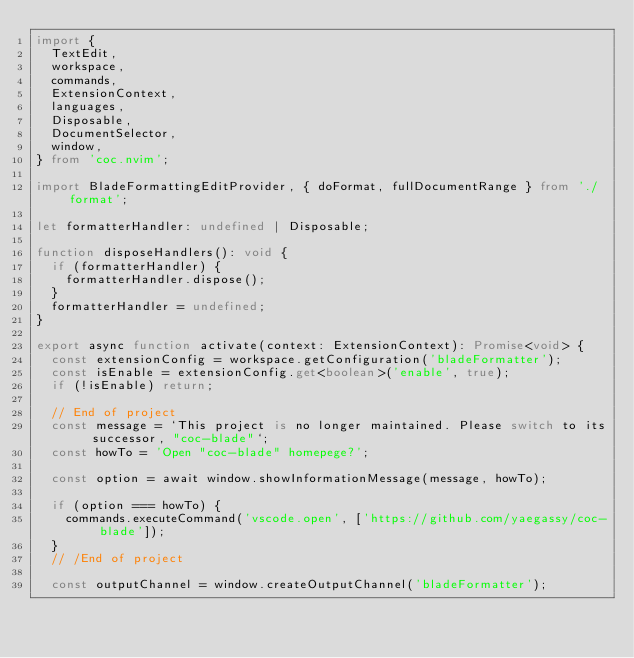<code> <loc_0><loc_0><loc_500><loc_500><_TypeScript_>import {
  TextEdit,
  workspace,
  commands,
  ExtensionContext,
  languages,
  Disposable,
  DocumentSelector,
  window,
} from 'coc.nvim';

import BladeFormattingEditProvider, { doFormat, fullDocumentRange } from './format';

let formatterHandler: undefined | Disposable;

function disposeHandlers(): void {
  if (formatterHandler) {
    formatterHandler.dispose();
  }
  formatterHandler = undefined;
}

export async function activate(context: ExtensionContext): Promise<void> {
  const extensionConfig = workspace.getConfiguration('bladeFormatter');
  const isEnable = extensionConfig.get<boolean>('enable', true);
  if (!isEnable) return;

  // End of project
  const message = `This project is no longer maintained. Please switch to its successor, "coc-blade"`;
  const howTo = 'Open "coc-blade" homepege?';

  const option = await window.showInformationMessage(message, howTo);

  if (option === howTo) {
    commands.executeCommand('vscode.open', ['https://github.com/yaegassy/coc-blade']);
  }
  // /End of project

  const outputChannel = window.createOutputChannel('bladeFormatter');
</code> 